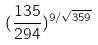<formula> <loc_0><loc_0><loc_500><loc_500>( \frac { 1 3 5 } { 2 9 4 } ) ^ { 9 / \sqrt { 3 5 9 } }</formula> 